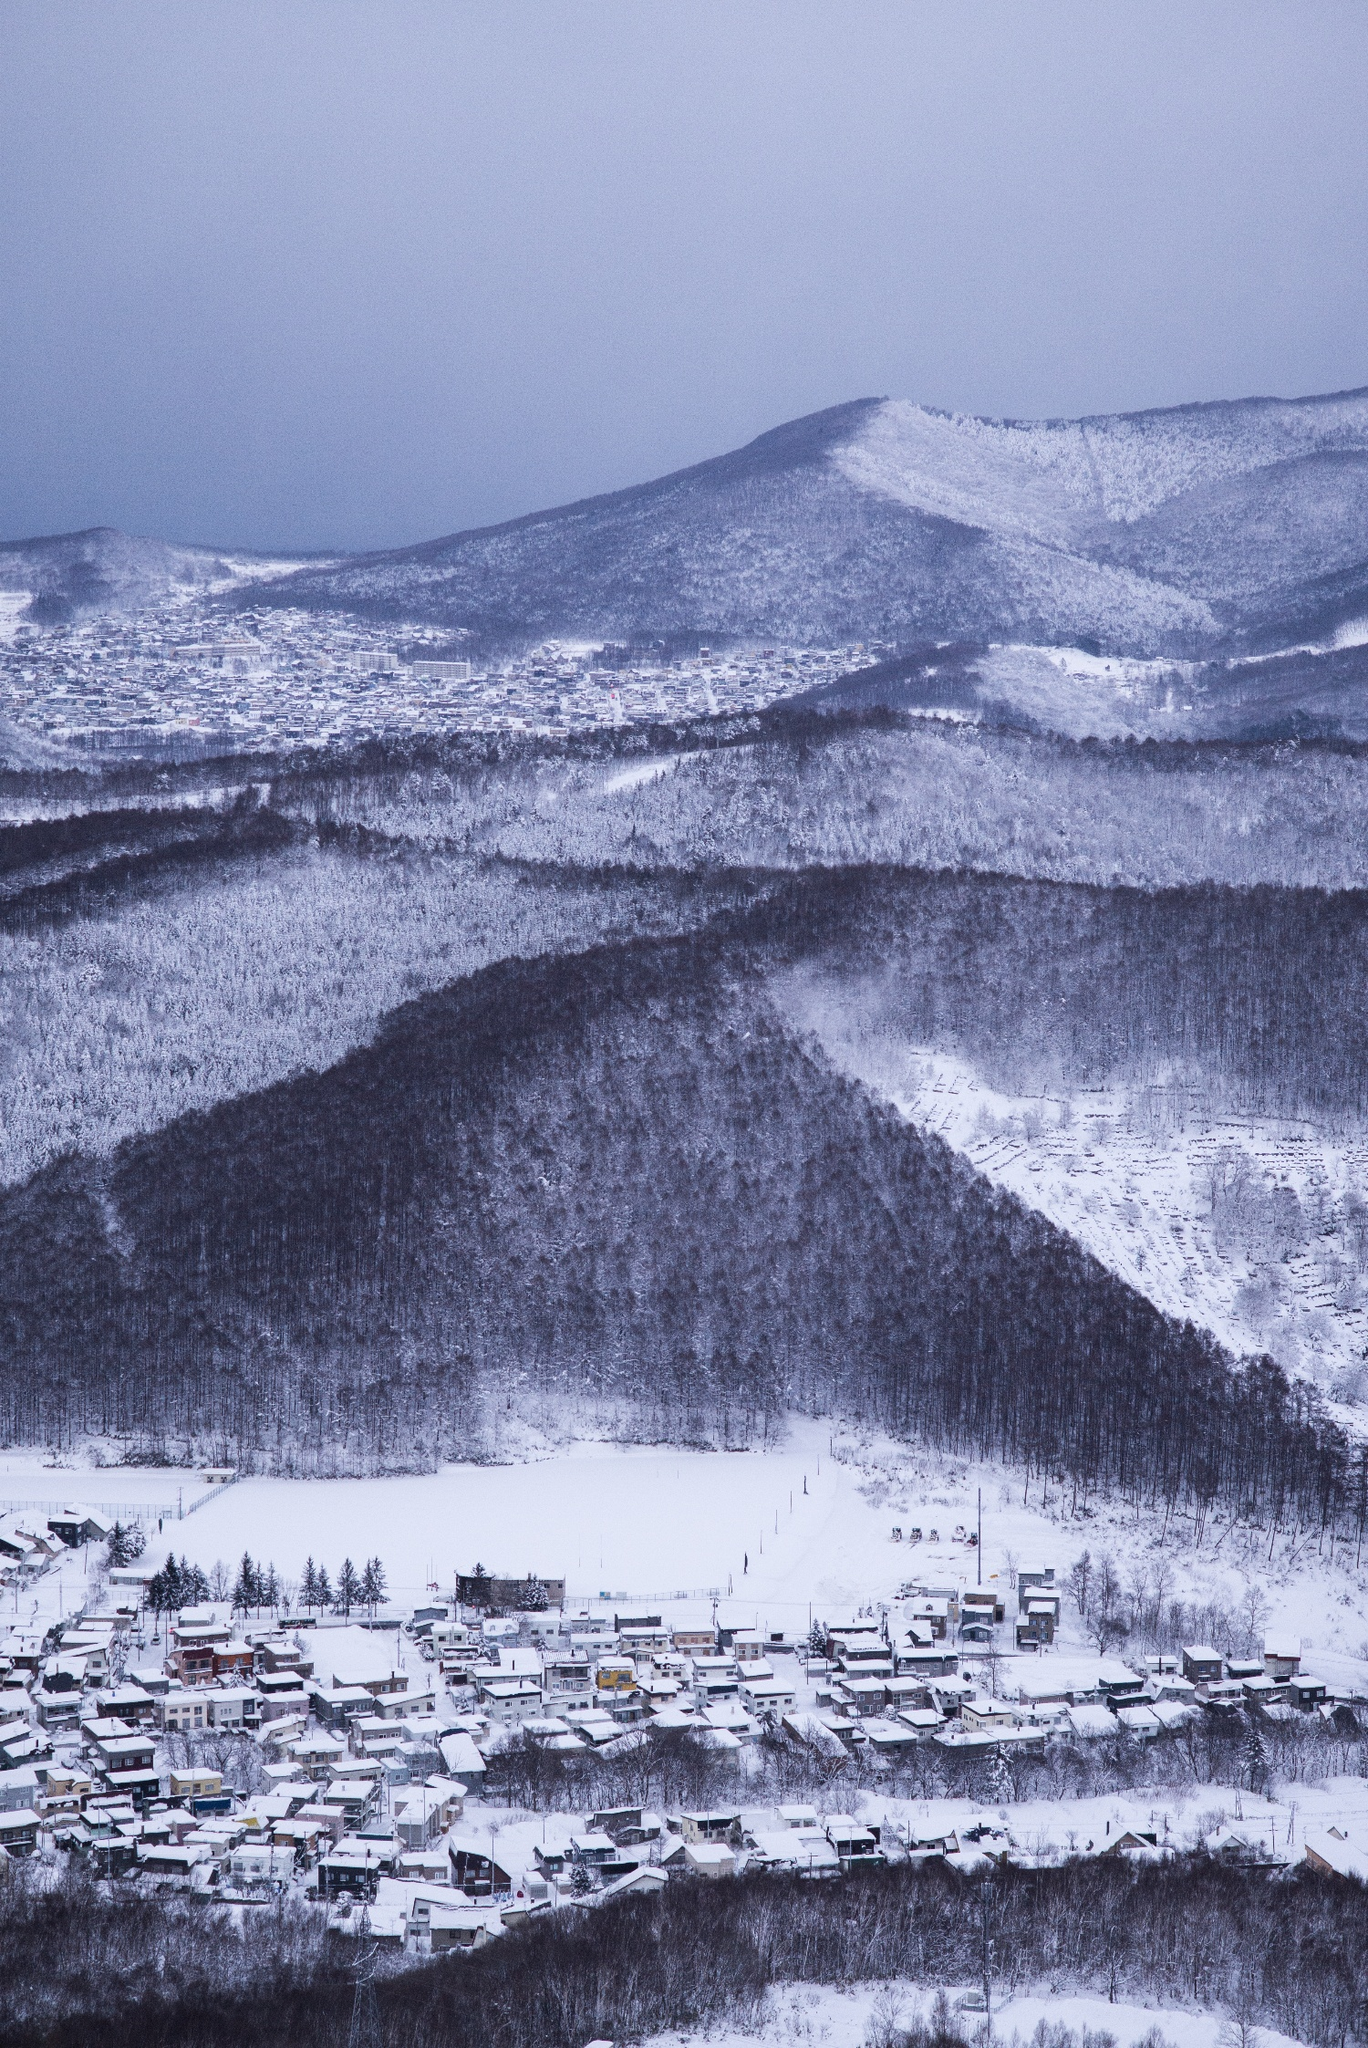What might be the daily life like for residents in this isolated snowy town? Daily life in this snowy town is likely shaped by the seasonal conditions. Residents may engage in activities like snow shoveling, using snowmobiles for transportation, and participating in winter sports such as skiing or snowboarding nearby. The community likely relies heavily on local resources and maintains tight-knit relationships to cope with the challenges posed by their environment. Winter festivals and indoor gatherings might be common, providing warmth and social connection during the long, cold months. 